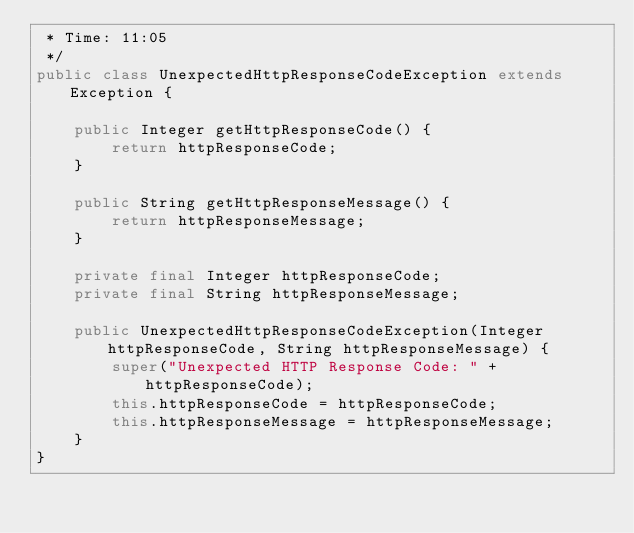Convert code to text. <code><loc_0><loc_0><loc_500><loc_500><_Java_> * Time: 11:05
 */
public class UnexpectedHttpResponseCodeException extends Exception {

    public Integer getHttpResponseCode() {
        return httpResponseCode;
    }

    public String getHttpResponseMessage() {
        return httpResponseMessage;
    }

    private final Integer httpResponseCode;
    private final String httpResponseMessage;

    public UnexpectedHttpResponseCodeException(Integer httpResponseCode, String httpResponseMessage) {
        super("Unexpected HTTP Response Code: " + httpResponseCode);
        this.httpResponseCode = httpResponseCode;
        this.httpResponseMessage = httpResponseMessage;
    }
}
</code> 